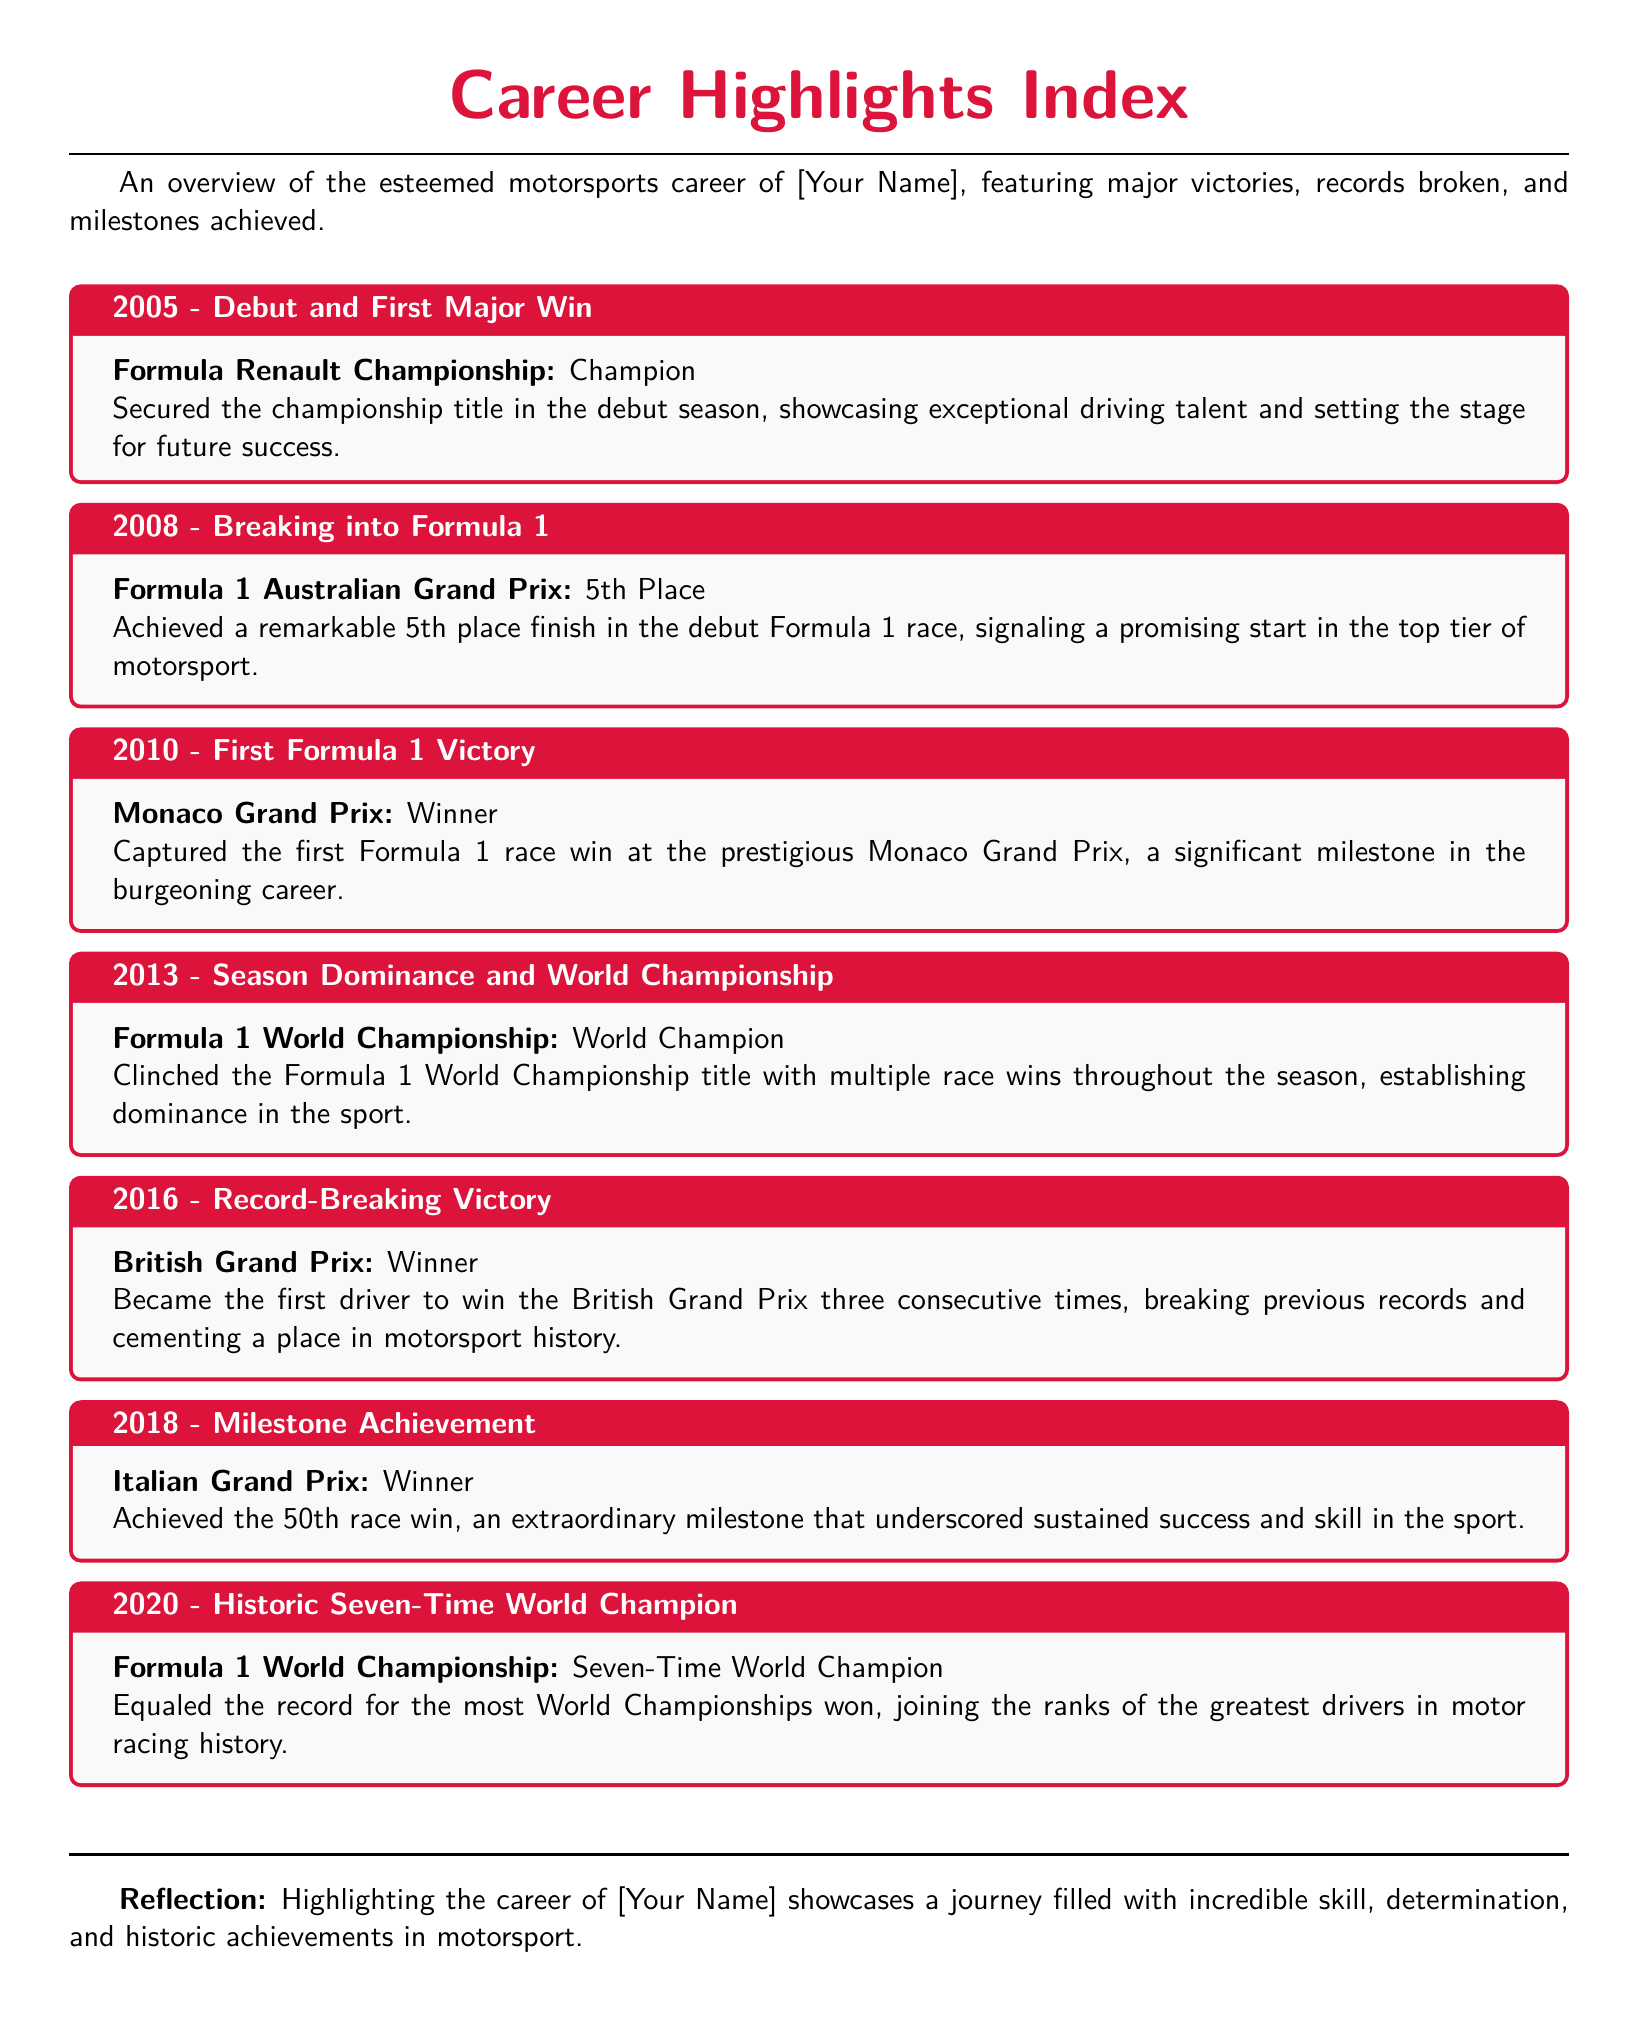What year did the driver debut in motorsports? The document states that the driver debuted in 2005.
Answer: 2005 What was the first major win achieved by the driver? According to the document, the driver secured the championship title in the Formula Renault Championship.
Answer: Champion In what year did the driver achieve their first Formula 1 victory? The document indicates that the driver won their first Formula 1 race in 2010.
Answer: 2010 How many times has the driver won the Formula 1 World Championship? The document highlights that the driver has won the Formula 1 World Championship seven times.
Answer: Seven Which race is noted for becoming a record-breaking victory? The British Grand Prix is mentioned as the race where the driver broke the record.
Answer: British Grand Prix What significant milestone was achieved in the year 2018? The document mentions that the driver achieved 50 race wins in 2018.
Answer: 50th race win Which prestigious race did the driver win in Monaco? The document references the Monaco Grand Prix as the race won in 2010.
Answer: Monaco Grand Prix What is a major theme present in the highlights of the driver's career? The document reflects on the journey filled with incredible skill and determination.
Answer: Skill and determination What accomplishment is listed for the year 2020? The document states that the driver became a seven-time world champion in 2020.
Answer: Seven-Time World Champion 